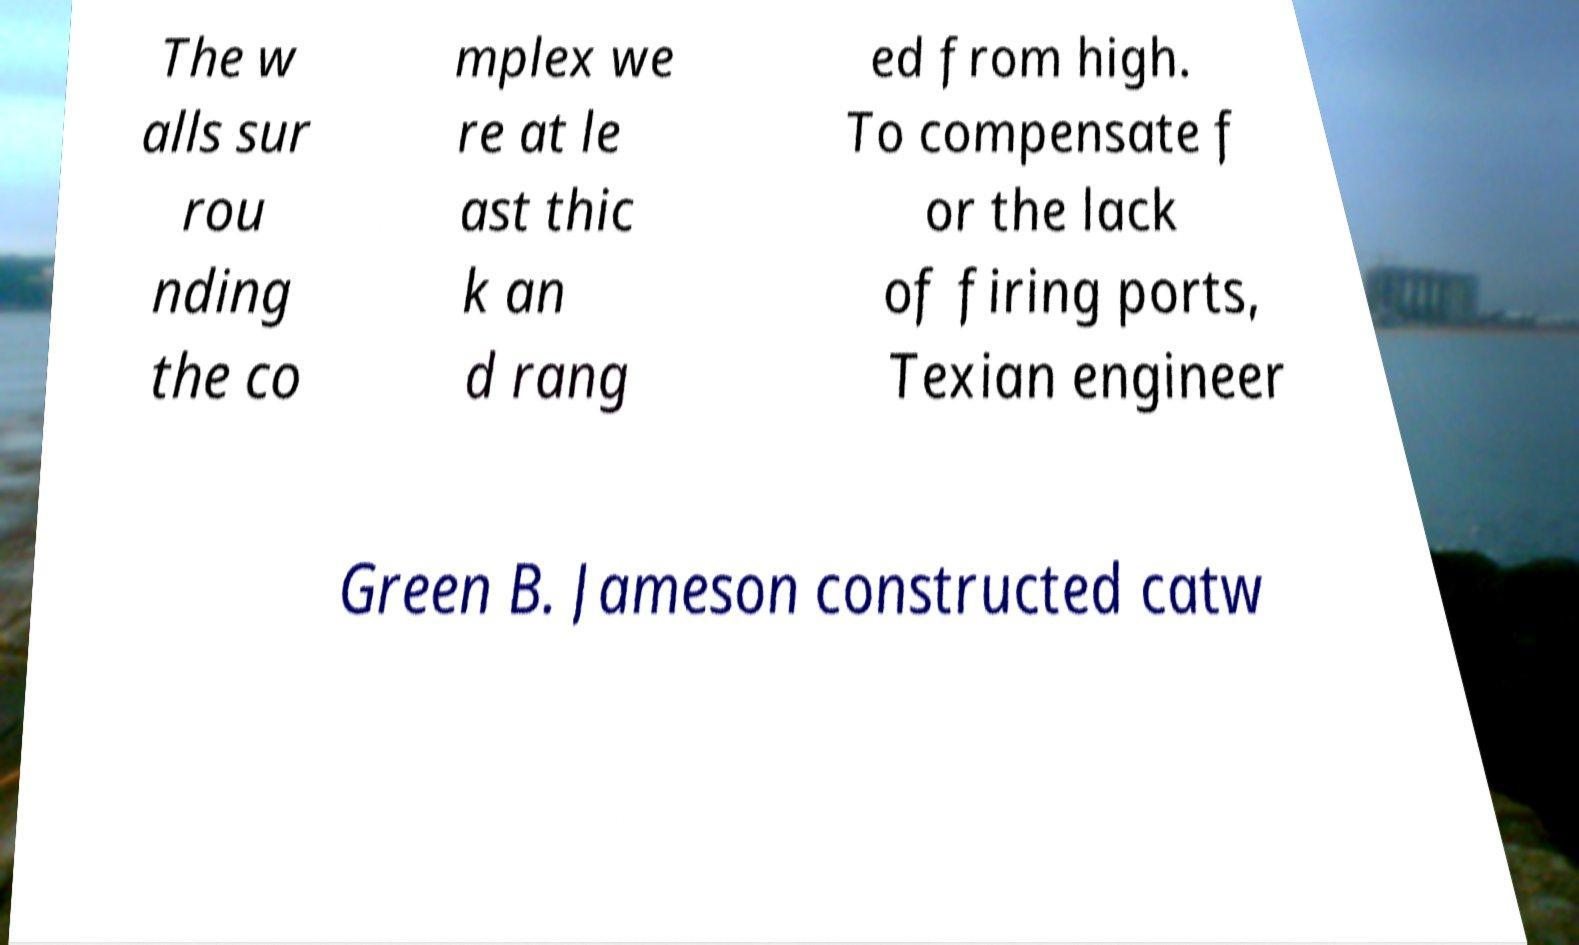I need the written content from this picture converted into text. Can you do that? The w alls sur rou nding the co mplex we re at le ast thic k an d rang ed from high. To compensate f or the lack of firing ports, Texian engineer Green B. Jameson constructed catw 